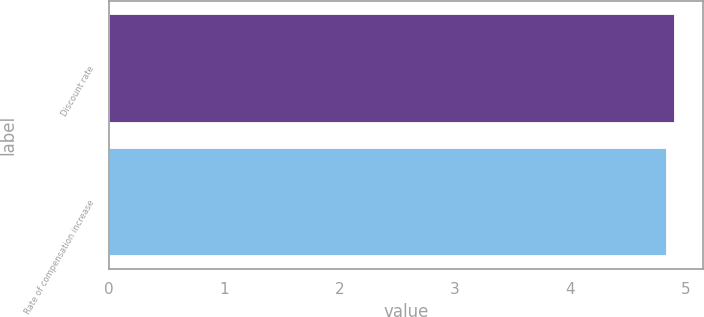Convert chart. <chart><loc_0><loc_0><loc_500><loc_500><bar_chart><fcel>Discount rate<fcel>Rate of compensation increase<nl><fcel>4.9<fcel>4.83<nl></chart> 